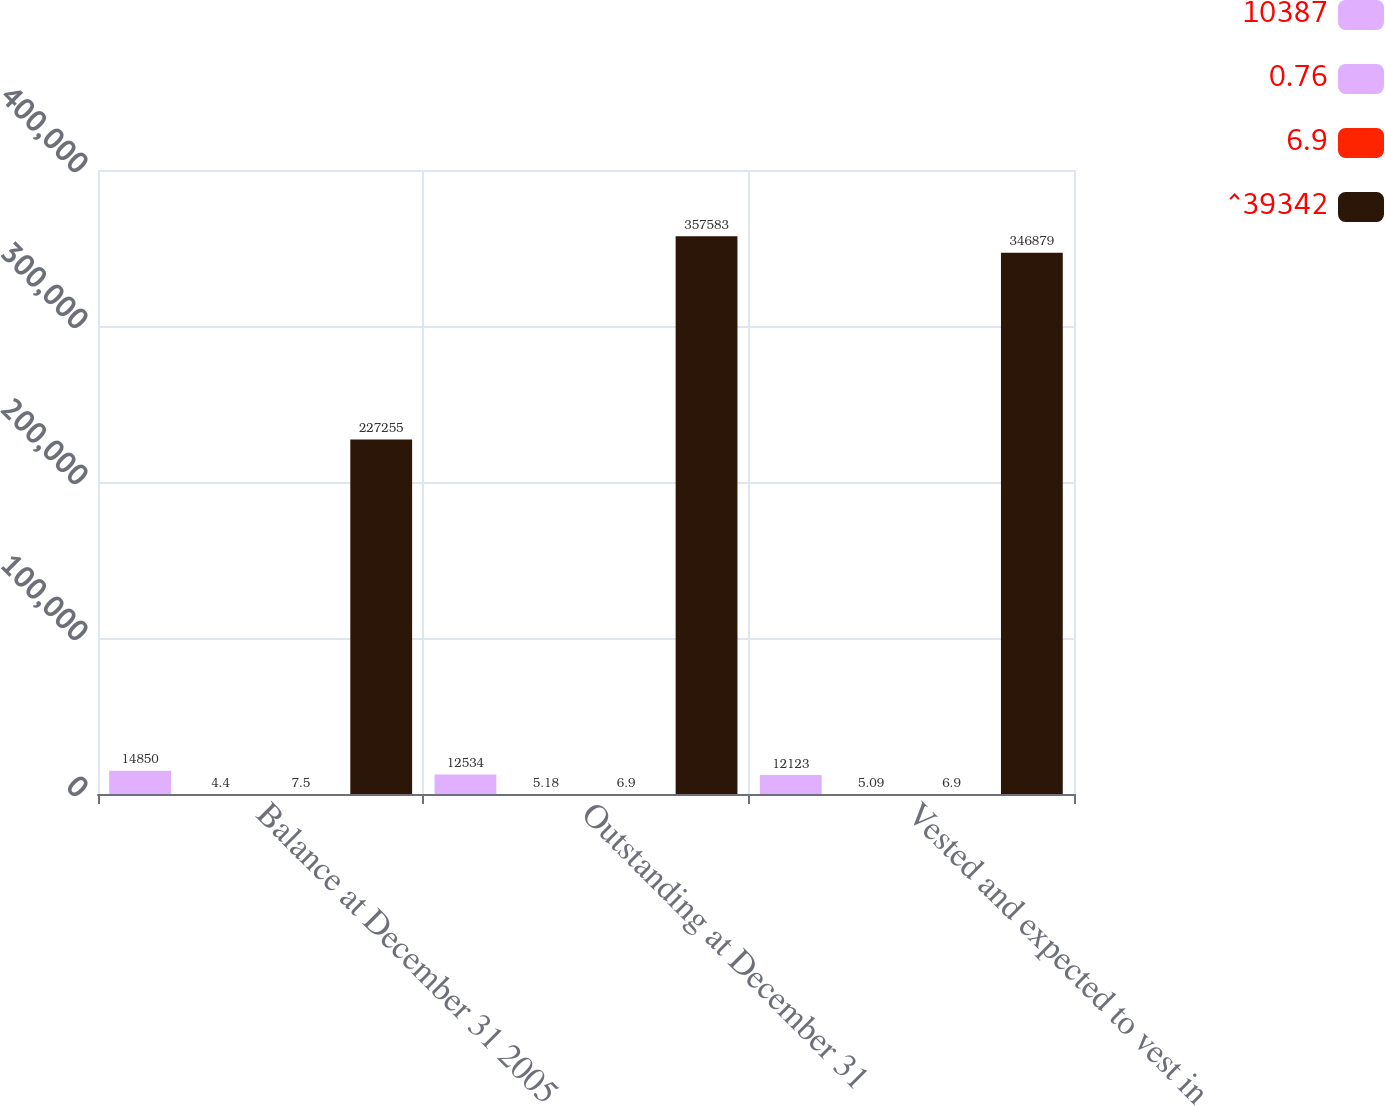Convert chart to OTSL. <chart><loc_0><loc_0><loc_500><loc_500><stacked_bar_chart><ecel><fcel>Balance at December 31 2005<fcel>Outstanding at December 31<fcel>Vested and expected to vest in<nl><fcel>10387<fcel>14850<fcel>12534<fcel>12123<nl><fcel>0.76<fcel>4.4<fcel>5.18<fcel>5.09<nl><fcel>6.9<fcel>7.5<fcel>6.9<fcel>6.9<nl><fcel>^39342<fcel>227255<fcel>357583<fcel>346879<nl></chart> 